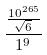Convert formula to latex. <formula><loc_0><loc_0><loc_500><loc_500>\frac { \frac { 1 0 ^ { 2 6 5 } } { \sqrt { 6 } } } { 1 ^ { 9 } }</formula> 